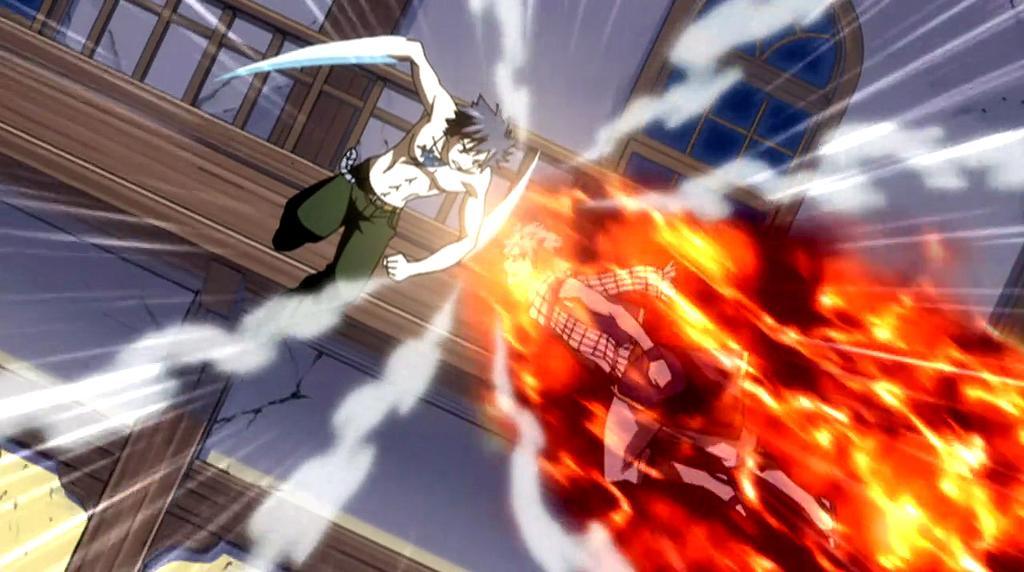In one or two sentences, can you explain what this image depicts? This is an animated image of two persons, building and fire. 